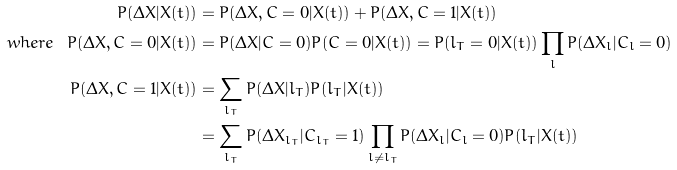Convert formula to latex. <formula><loc_0><loc_0><loc_500><loc_500>P ( \Delta X | X ( t ) ) & = P ( \Delta X , C = 0 | X ( t ) ) + P ( \Delta X , C = 1 | X ( t ) ) \\ w h e r e \ \ P ( \Delta X , C = 0 | X ( t ) ) & = P ( \Delta X | C = 0 ) P ( C = 0 | X ( t ) ) = P ( l _ { T } = 0 | X ( t ) ) \prod _ { l } P ( \Delta X _ { l } | C _ { l } = 0 ) \\ P ( \Delta X , C = 1 | X ( t ) ) & = \sum _ { l _ { T } } P ( \Delta X | l _ { T } ) P ( l _ { T } | X ( t ) ) \\ & = \sum _ { l _ { T } } P ( \Delta X _ { l _ { T } } | C _ { l _ { T } } = 1 ) \prod _ { l \neq l _ { T } } P ( \Delta X _ { l } | C _ { l } = 0 ) P ( l _ { T } | X ( t ) )</formula> 